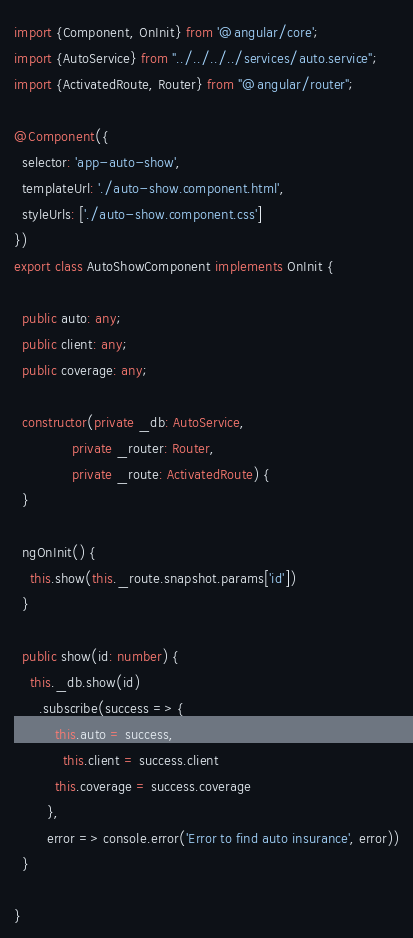Convert code to text. <code><loc_0><loc_0><loc_500><loc_500><_TypeScript_>import {Component, OnInit} from '@angular/core';
import {AutoService} from "../../../../services/auto.service";
import {ActivatedRoute, Router} from "@angular/router";

@Component({
  selector: 'app-auto-show',
  templateUrl: './auto-show.component.html',
  styleUrls: ['./auto-show.component.css']
})
export class AutoShowComponent implements OnInit {

  public auto: any;
  public client: any;
  public coverage: any;

  constructor(private _db: AutoService,
              private _router: Router,
              private _route: ActivatedRoute) {
  }

  ngOnInit() {
    this.show(this._route.snapshot.params['id'])
  }

  public show(id: number) {
    this._db.show(id)
      .subscribe(success => {
          this.auto = success,
            this.client = success.client
          this.coverage = success.coverage
        },
        error => console.error('Error to find auto insurance', error))
  }

}
</code> 